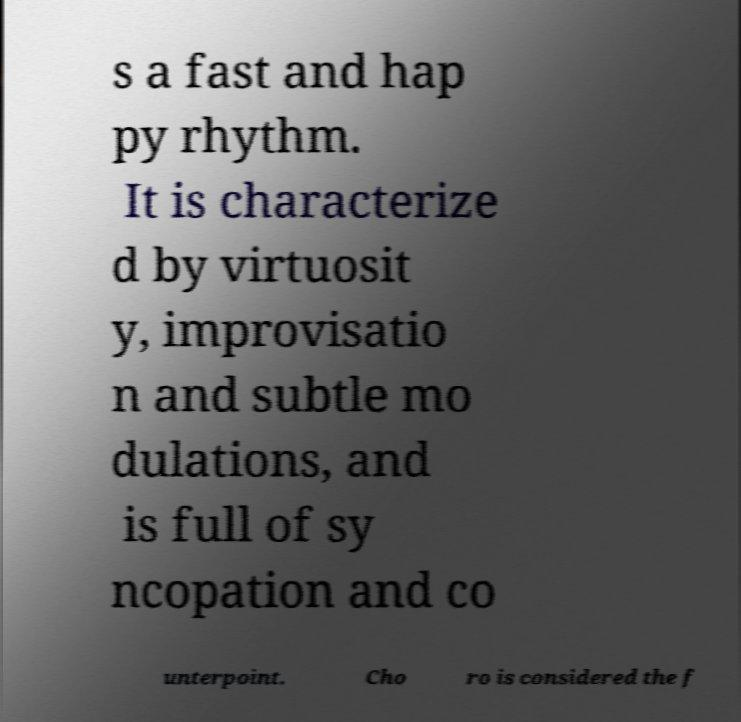For documentation purposes, I need the text within this image transcribed. Could you provide that? s a fast and hap py rhythm. It is characterize d by virtuosit y, improvisatio n and subtle mo dulations, and is full of sy ncopation and co unterpoint. Cho ro is considered the f 